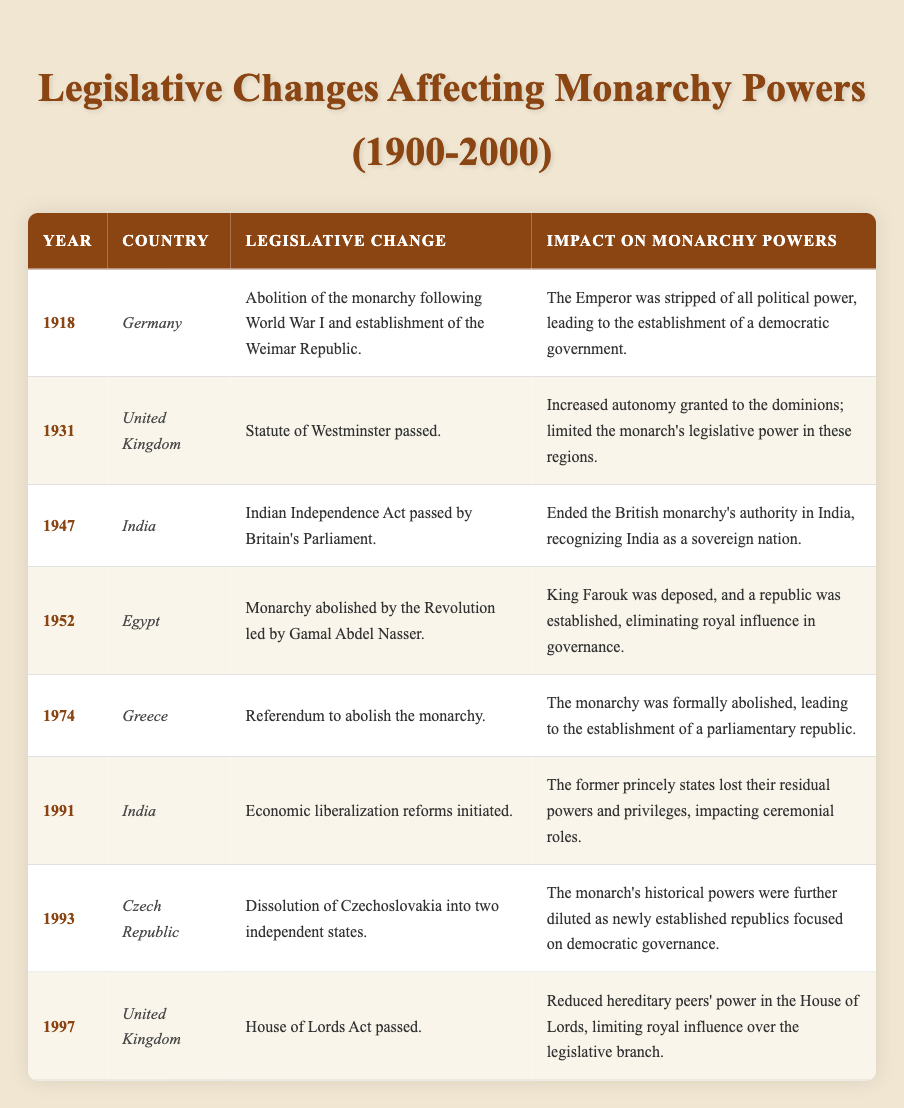What year did Germany abolish its monarchy? The table indicates that Germany abolished its monarchy in 1918.
Answer: 1918 Which legislative change in India occurred first? The Indian Independence Act passed in 1947 occurred before the economic liberalization reforms initiated in 1991.
Answer: Indian Independence Act in 1947 How many legislative changes were recorded for the United Kingdom? There are two legislative changes noted for the United Kingdom: the Statute of Westminster in 1931 and the House of Lords Act in 1997.
Answer: 2 What was the impact of the Statute of Westminster on the monarchy's powers in the United Kingdom? The Statute of Westminster in 1931 increased autonomy granted to the dominions and limited the monarch's legislative power in those regions.
Answer: Limited legislative power Was the monarchy formally abolished in Greece? Yes, the table states that a referendum to abolish the monarchy occurred in Greece in 1974, confirming its formal abolition.
Answer: Yes In which year did the Czech Republic experience a legislative change that diluted the monarch's historical powers? The legislative change occurred in 1993 when Czechoslovakia was dissolved into two independent states, impacting the monarch's historical powers.
Answer: 1993 What was the impact of the House of Lords Act passed in 1997 in the United Kingdom? The impact was a reduction of hereditary peers' power in the House of Lords, thereby limiting royal influence over the legislative branch.
Answer: Reduced royal influence Which country saw the monarchy abolished due to a revolution led by Gamal Abdel Nasser? The table shows that Egypt saw its monarchy abolished in 1952 due to the revolution led by Gamal Abdel Nasser.
Answer: Egypt How does the impact of the Indian Independence Act compare to the legislative changes in Egypt and Greece regarding monarchy powers? Both the Indian Independence Act in 1947 and the abolition of the monarchy in Egypt in 1952 led to a complete end to royal authority, similar to the formal abolition in Greece in 1974, indicating a broader decline of monarchy powers.
Answer: Complete end to royal authority Was there a legislative change affecting the monarchy powers in both the 20th century and a change that impacted the former princely states in India? Yes, the economic liberalization reforms initiated in India in 1991 impacted the former princely states, while multiple changes in the 20th century affected monarchy powers in various countries listed.
Answer: Yes What is the earliest year in the table that lists a legislative change affecting monarchy powers? The earliest year listed in the table is 1918, when Germany abolished its monarchy.
Answer: 1918 